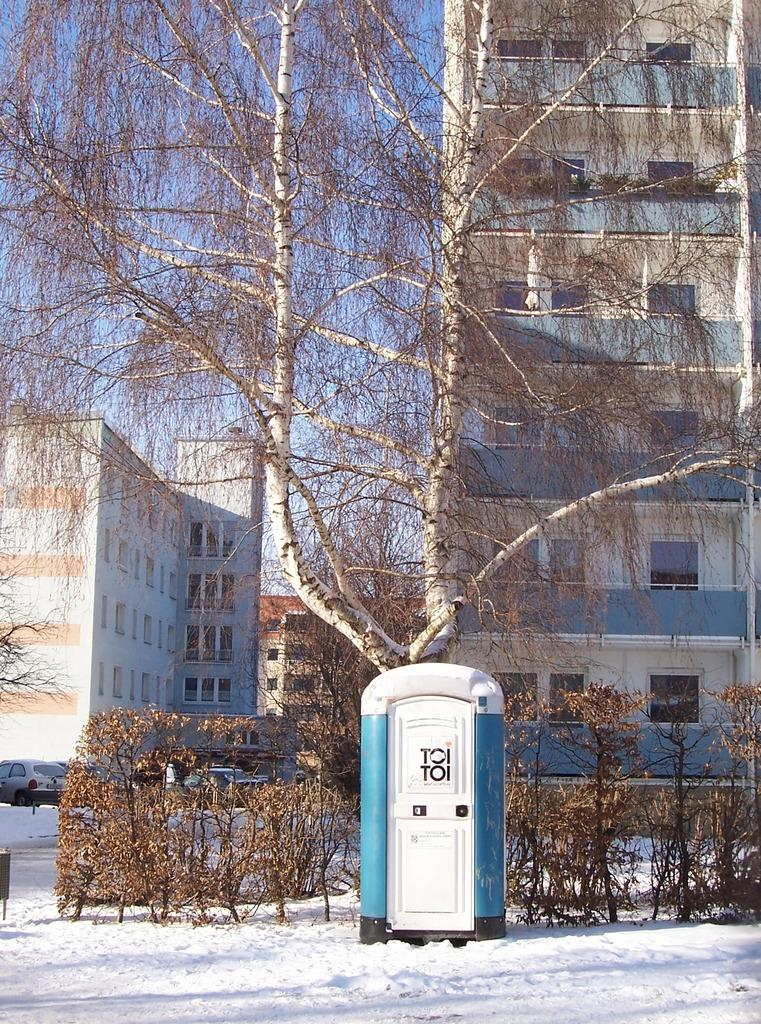What is the main subject on the snow in the image? There is an object on the snow, but the specific object is not mentioned in the facts. What can be seen in the background of the image? In the background, there are dried trees, plants, and buildings. Can you describe the vegetation in the background? The vegetation in the background includes dried trees and plants. What type of structures are visible in the background? Buildings are visible in the background. What type of fish can be seen swimming in the snow in the image? There are no fish present in the image, as it features an object on the snow and vegetation and structures in the background. 